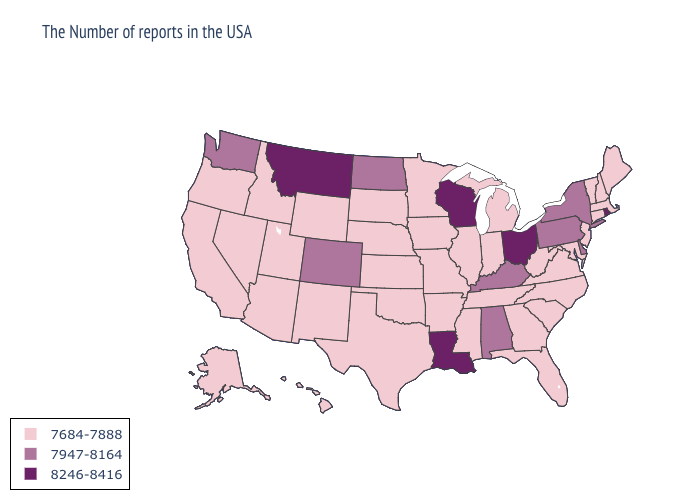Name the states that have a value in the range 8246-8416?
Be succinct. Rhode Island, Ohio, Wisconsin, Louisiana, Montana. Does the first symbol in the legend represent the smallest category?
Write a very short answer. Yes. What is the value of Iowa?
Give a very brief answer. 7684-7888. What is the highest value in the West ?
Quick response, please. 8246-8416. What is the lowest value in states that border Michigan?
Short answer required. 7684-7888. Does New Mexico have a lower value than Arkansas?
Write a very short answer. No. What is the value of Utah?
Answer briefly. 7684-7888. Name the states that have a value in the range 7684-7888?
Keep it brief. Maine, Massachusetts, New Hampshire, Vermont, Connecticut, New Jersey, Maryland, Virginia, North Carolina, South Carolina, West Virginia, Florida, Georgia, Michigan, Indiana, Tennessee, Illinois, Mississippi, Missouri, Arkansas, Minnesota, Iowa, Kansas, Nebraska, Oklahoma, Texas, South Dakota, Wyoming, New Mexico, Utah, Arizona, Idaho, Nevada, California, Oregon, Alaska, Hawaii. What is the value of New Hampshire?
Be succinct. 7684-7888. How many symbols are there in the legend?
Be succinct. 3. What is the value of Maryland?
Short answer required. 7684-7888. What is the highest value in the South ?
Short answer required. 8246-8416. What is the value of Arizona?
Keep it brief. 7684-7888. What is the value of Idaho?
Quick response, please. 7684-7888. Does Delaware have the lowest value in the USA?
Answer briefly. No. 